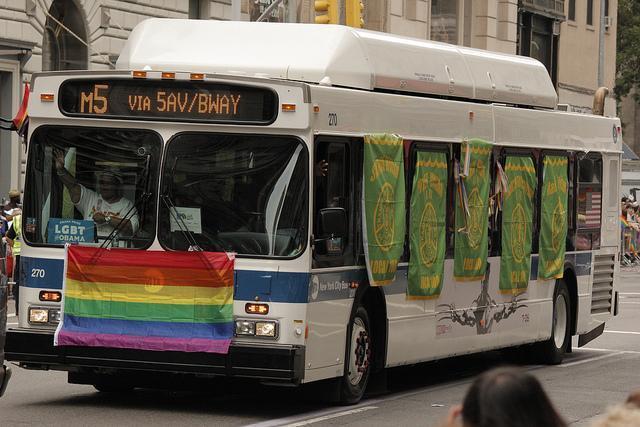How many vehicles are the street?
Give a very brief answer. 1. How many buses are in the picture?
Give a very brief answer. 1. How many people are visible?
Give a very brief answer. 2. 